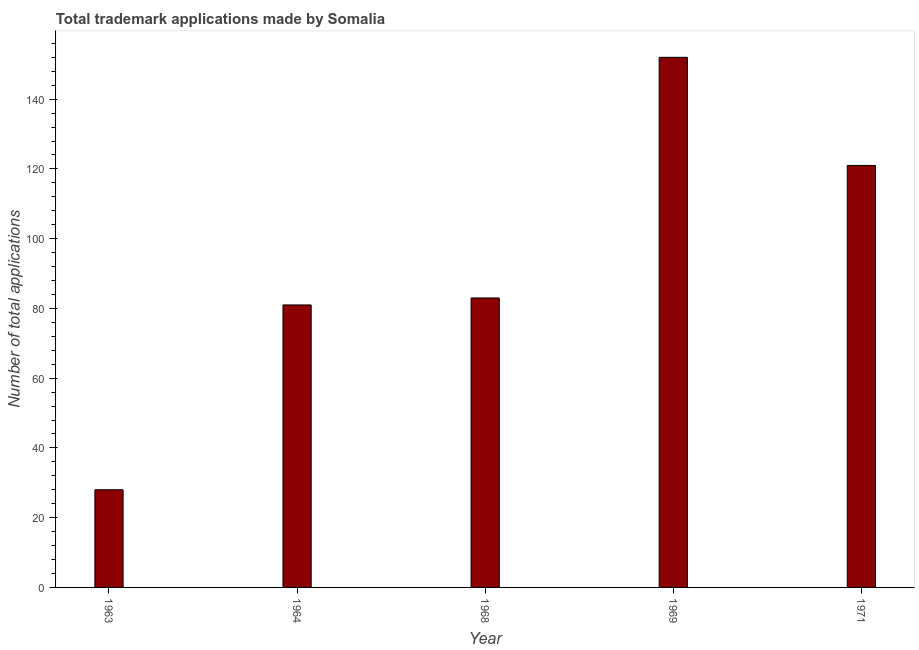Does the graph contain any zero values?
Your answer should be very brief. No. Does the graph contain grids?
Provide a succinct answer. No. What is the title of the graph?
Ensure brevity in your answer.  Total trademark applications made by Somalia. What is the label or title of the Y-axis?
Offer a terse response. Number of total applications. What is the number of trademark applications in 1971?
Your answer should be very brief. 121. Across all years, what is the maximum number of trademark applications?
Give a very brief answer. 152. Across all years, what is the minimum number of trademark applications?
Ensure brevity in your answer.  28. In which year was the number of trademark applications maximum?
Your answer should be very brief. 1969. What is the sum of the number of trademark applications?
Ensure brevity in your answer.  465. What is the difference between the number of trademark applications in 1969 and 1971?
Your answer should be compact. 31. What is the average number of trademark applications per year?
Keep it short and to the point. 93. What is the median number of trademark applications?
Your answer should be very brief. 83. In how many years, is the number of trademark applications greater than 80 ?
Provide a succinct answer. 4. Do a majority of the years between 1964 and 1971 (inclusive) have number of trademark applications greater than 8 ?
Ensure brevity in your answer.  Yes. What is the ratio of the number of trademark applications in 1963 to that in 1971?
Ensure brevity in your answer.  0.23. What is the difference between the highest and the second highest number of trademark applications?
Your answer should be very brief. 31. Is the sum of the number of trademark applications in 1964 and 1971 greater than the maximum number of trademark applications across all years?
Provide a succinct answer. Yes. What is the difference between the highest and the lowest number of trademark applications?
Your answer should be very brief. 124. In how many years, is the number of trademark applications greater than the average number of trademark applications taken over all years?
Provide a short and direct response. 2. How many bars are there?
Make the answer very short. 5. Are all the bars in the graph horizontal?
Ensure brevity in your answer.  No. What is the difference between two consecutive major ticks on the Y-axis?
Keep it short and to the point. 20. Are the values on the major ticks of Y-axis written in scientific E-notation?
Offer a terse response. No. What is the Number of total applications in 1963?
Keep it short and to the point. 28. What is the Number of total applications in 1969?
Your answer should be very brief. 152. What is the Number of total applications of 1971?
Ensure brevity in your answer.  121. What is the difference between the Number of total applications in 1963 and 1964?
Provide a succinct answer. -53. What is the difference between the Number of total applications in 1963 and 1968?
Provide a succinct answer. -55. What is the difference between the Number of total applications in 1963 and 1969?
Keep it short and to the point. -124. What is the difference between the Number of total applications in 1963 and 1971?
Offer a terse response. -93. What is the difference between the Number of total applications in 1964 and 1969?
Your answer should be very brief. -71. What is the difference between the Number of total applications in 1968 and 1969?
Your response must be concise. -69. What is the difference between the Number of total applications in 1968 and 1971?
Keep it short and to the point. -38. What is the ratio of the Number of total applications in 1963 to that in 1964?
Offer a very short reply. 0.35. What is the ratio of the Number of total applications in 1963 to that in 1968?
Your answer should be compact. 0.34. What is the ratio of the Number of total applications in 1963 to that in 1969?
Your answer should be very brief. 0.18. What is the ratio of the Number of total applications in 1963 to that in 1971?
Offer a very short reply. 0.23. What is the ratio of the Number of total applications in 1964 to that in 1968?
Your answer should be very brief. 0.98. What is the ratio of the Number of total applications in 1964 to that in 1969?
Offer a terse response. 0.53. What is the ratio of the Number of total applications in 1964 to that in 1971?
Provide a succinct answer. 0.67. What is the ratio of the Number of total applications in 1968 to that in 1969?
Give a very brief answer. 0.55. What is the ratio of the Number of total applications in 1968 to that in 1971?
Provide a short and direct response. 0.69. What is the ratio of the Number of total applications in 1969 to that in 1971?
Offer a terse response. 1.26. 